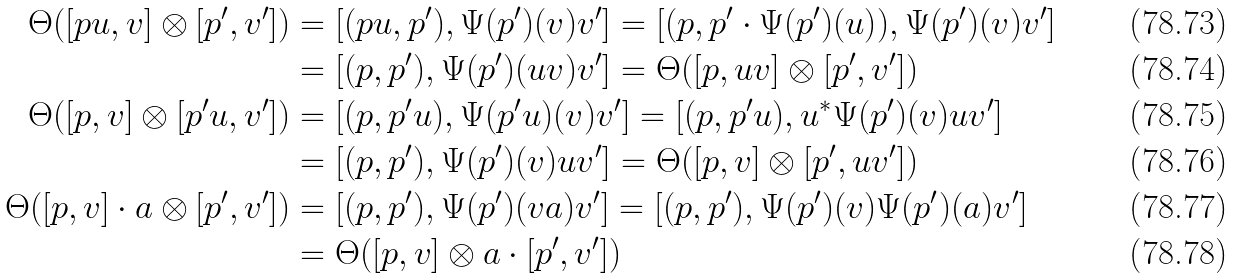<formula> <loc_0><loc_0><loc_500><loc_500>\Theta ( [ p u , v ] \otimes [ p ^ { \prime } , v ^ { \prime } ] ) & = [ ( p u , p ^ { \prime } ) , \Psi ( p ^ { \prime } ) ( v ) v ^ { \prime } ] = [ ( p , p ^ { \prime } \cdot \Psi ( p ^ { \prime } ) ( u ) ) , \Psi ( p ^ { \prime } ) ( v ) v ^ { \prime } ] \\ & = [ ( p , p ^ { \prime } ) , \Psi ( p ^ { \prime } ) ( u v ) v ^ { \prime } ] = \Theta ( [ p , u v ] \otimes [ p ^ { \prime } , v ^ { \prime } ] ) \\ \Theta ( [ p , v ] \otimes [ p ^ { \prime } u , v ^ { \prime } ] ) & = [ ( p , p ^ { \prime } u ) , \Psi ( p ^ { \prime } u ) ( v ) v ^ { \prime } ] = [ ( p , p ^ { \prime } u ) , u ^ { * } \Psi ( p ^ { \prime } ) ( v ) u v ^ { \prime } ] \\ & = [ ( p , p ^ { \prime } ) , \Psi ( p ^ { \prime } ) ( v ) u v ^ { \prime } ] = \Theta ( [ p , v ] \otimes [ p ^ { \prime } , u v ^ { \prime } ] ) \\ \Theta ( [ p , v ] \cdot a \otimes [ p ^ { \prime } , v ^ { \prime } ] ) & = [ ( p , p ^ { \prime } ) , \Psi ( p ^ { \prime } ) ( v a ) v ^ { \prime } ] = [ ( p , p ^ { \prime } ) , \Psi ( p ^ { \prime } ) ( v ) \Psi ( p ^ { \prime } ) ( a ) v ^ { \prime } ] \\ & = \Theta ( [ p , v ] \otimes a \cdot [ p ^ { \prime } , v ^ { \prime } ] )</formula> 